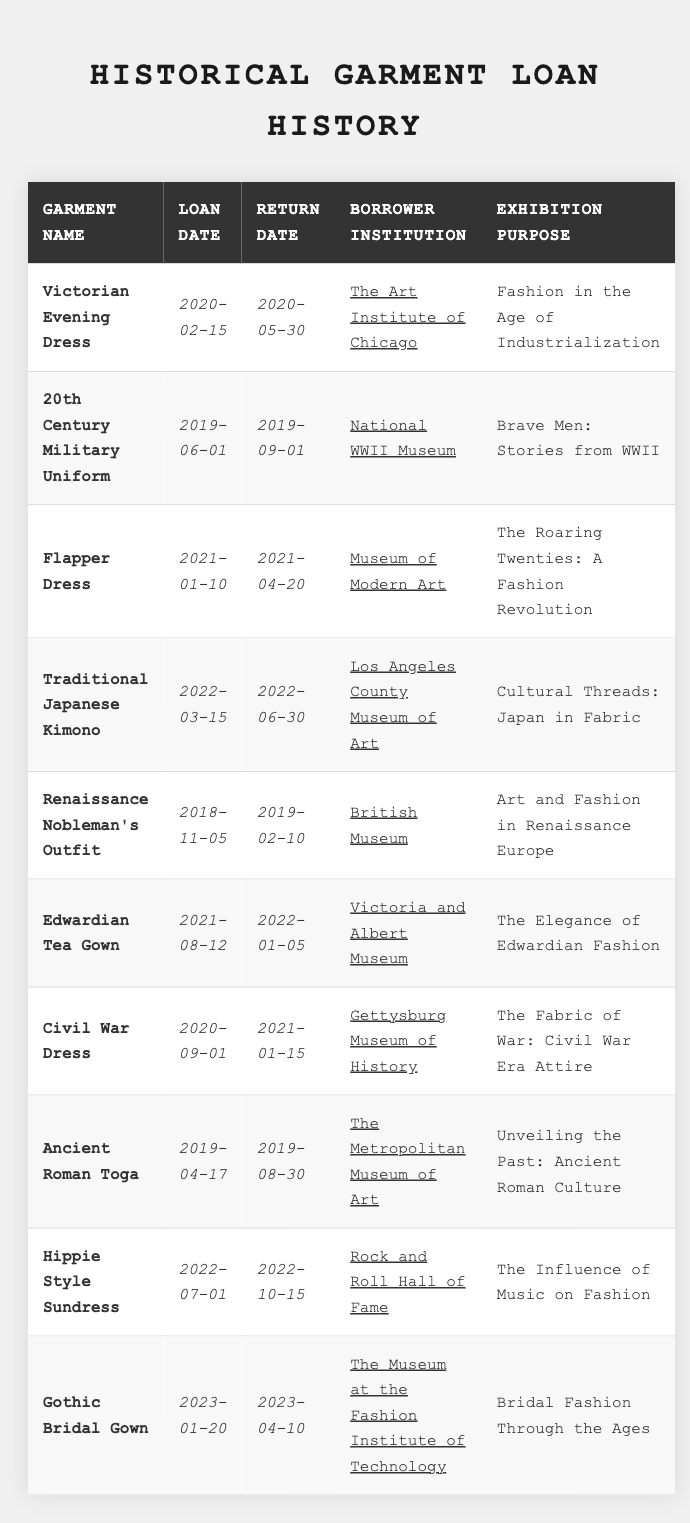What is the loan date for the "Victorian Evening Dress"? The "Victorian Evening Dress" has a loan date listed in the table as 2020-02-15.
Answer: 2020-02-15 Which institution borrowed the "Flapper Dress"? The borrower institution for the "Flapper Dress" is the Museum of Modern Art, as indicated in the table.
Answer: Museum of Modern Art What is the exhibition purpose for the "Gothic Bridal Gown"? The table shows that the exhibition purpose for the "Gothic Bridal Gown" is "Bridal Fashion Through the Ages."
Answer: Bridal Fashion Through the Ages How many garments were loaned to the "British Museum"? Only one garment, the "Renaissance Nobleman's Outfit," was loaned to the British Museum, as seen in the table.
Answer: 1 What was the return date for the "Civil War Dress"? The return date for the "Civil War Dress" is shown in the table as 2021-01-15.
Answer: 2021-01-15 Was the "20th Century Military Uniform" loaned for an exhibition? Yes, the "20th Century Military Uniform" was loaned for the exhibition "Brave Men: Stories from WWII." This indicates it was used for exhibition purposes.
Answer: Yes Which garment had the longest loan duration based on the table? To determine the longest loan duration, we calculate the duration for each garment. The "Victorian Evening Dress" was loaned for 105 days, the "Renaissance Nobleman's Outfit" for 96 days, and other garments are shorter. Therefore, the "Victorian Evening Dress" had the longest loan duration.
Answer: Victorian Evening Dress How many total garments were loaned out to institutions in 2022? From the table, there are three garments that were loaned out in 2022: "Traditional Japanese Kimono," "Hippie Style Sundress," and "Edwardian Tea Gown." Summing these gives a total of 3.
Answer: 3 Which garment was loaned during 2021? Reviewing the table, the garments loaned during 2021 include "Flapper Dress," "Edwardian Tea Gown," and "Gothic Bridal Gown," making for three garments in total.
Answer: Flapper Dress, Edwardian Tea Gown, Gothic Bridal Gown What was the earliest loan date in the table? Scanning the dates, the earliest loan date is 2018-11-05 for the "Renaissance Nobleman's Outfit," as it is the first date listed chronologically.
Answer: 2018-11-05 Who borrowed the "Ancient Roman Toga"? The table indicates that the "Ancient Roman Toga" was borrowed by The Metropolitan Museum of Art.
Answer: The Metropolitan Museum of Art 